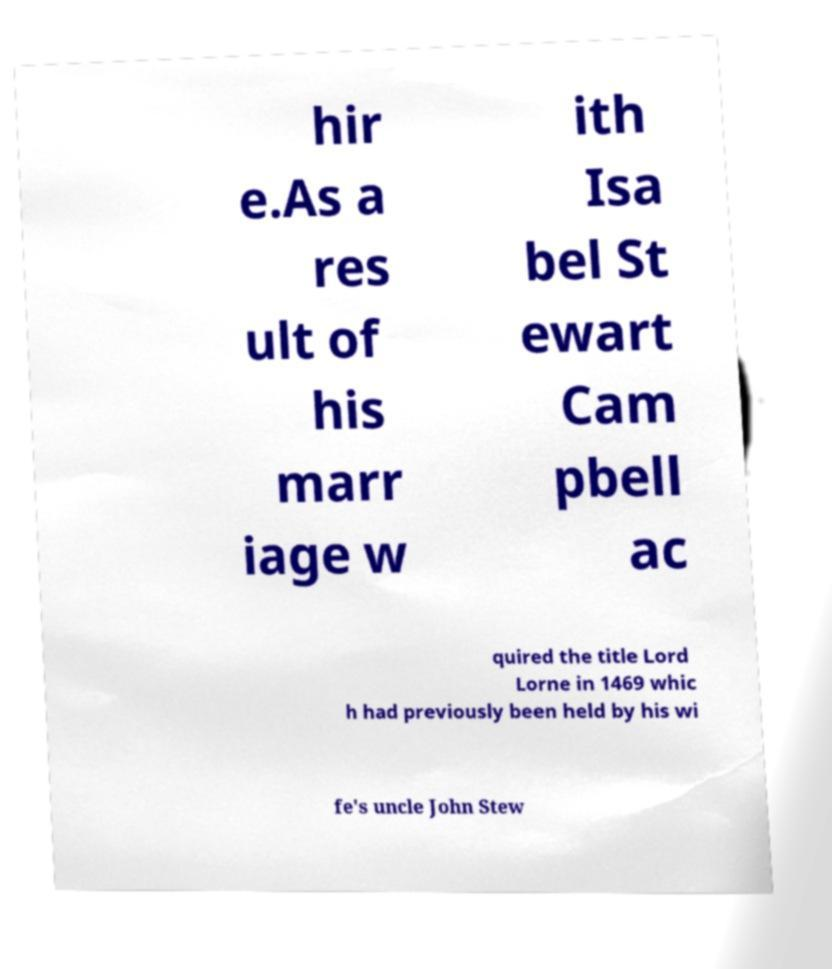Can you accurately transcribe the text from the provided image for me? hir e.As a res ult of his marr iage w ith Isa bel St ewart Cam pbell ac quired the title Lord Lorne in 1469 whic h had previously been held by his wi fe's uncle John Stew 